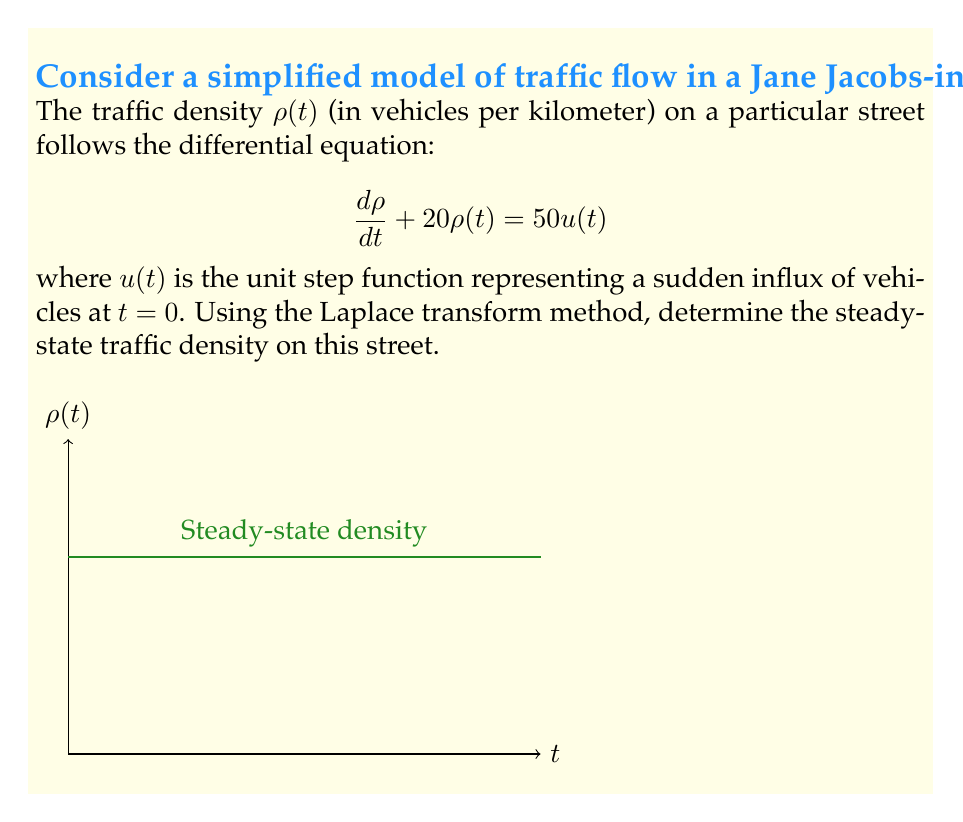Show me your answer to this math problem. Let's solve this step-by-step using the Laplace transform method:

1) Take the Laplace transform of both sides of the equation:
   $$\mathcal{L}\{\frac{d\rho}{dt} + 20\rho(t)\} = \mathcal{L}\{50u(t)\}$$

2) Using Laplace transform properties:
   $$s\mathcal{L}\{\rho(t)\} - \rho(0) + 20\mathcal{L}\{\rho(t)\} = \frac{50}{s}$$

3) Let $\mathcal{L}\{\rho(t)\} = R(s)$. Assume $\rho(0) = 0$ (initial density is zero):
   $$sR(s) + 20R(s) = \frac{50}{s}$$

4) Simplify:
   $$R(s)(s + 20) = \frac{50}{s}$$

5) Solve for $R(s)$:
   $$R(s) = \frac{50}{s(s + 20)}$$

6) Partial fraction decomposition:
   $$R(s) = \frac{A}{s} + \frac{B}{s + 20}$$

   where $A = \frac{50}{20} = 2.5$ and $B = -\frac{50}{20} = -2.5$

7) Take the inverse Laplace transform:
   $$\rho(t) = 2.5 - 2.5e^{-20t}$$

8) For the steady-state, take the limit as $t \to \infty$:
   $$\lim_{t \to \infty} \rho(t) = 2.5 - 2.5\lim_{t \to \infty}e^{-20t} = 2.5$$

Therefore, the steady-state traffic density is 2.5 vehicles per kilometer.
Answer: $2.5$ vehicles/km 